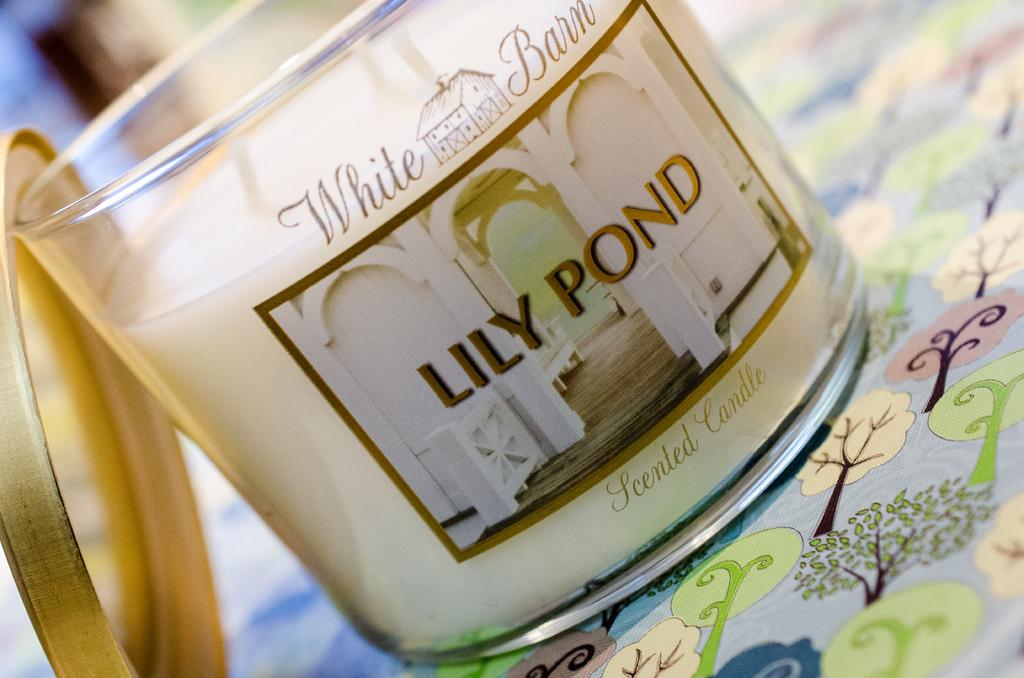<image>
Offer a succinct explanation of the picture presented. A white candle with a gold lid says White Barn Lily Pond. 